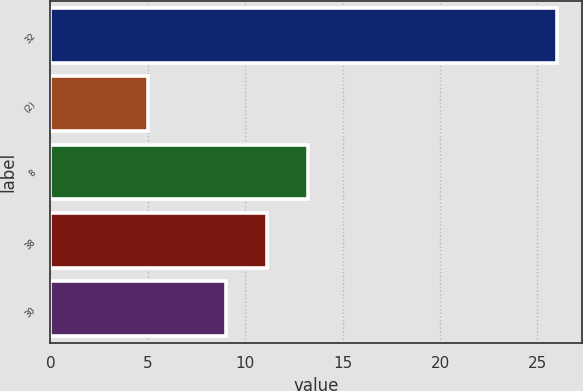Convert chart. <chart><loc_0><loc_0><loc_500><loc_500><bar_chart><fcel>32<fcel>(2)<fcel>8<fcel>38<fcel>30<nl><fcel>26<fcel>5<fcel>13.2<fcel>11.1<fcel>9<nl></chart> 